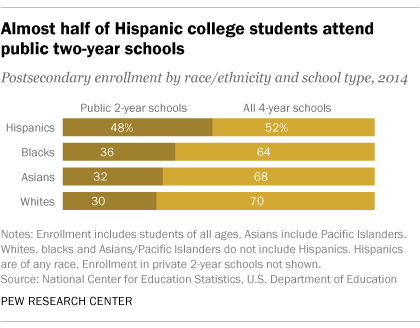Mention a couple of crucial points in this snapshot. The value of the highest yellow bar is 70. The difference between the highest and lowest percentage in all 4-year schools is 18%. 